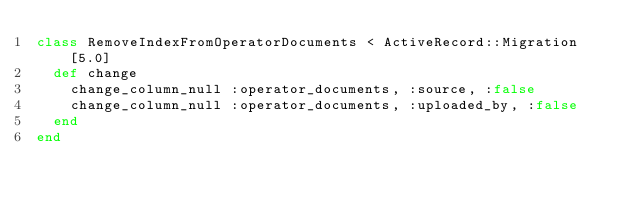Convert code to text. <code><loc_0><loc_0><loc_500><loc_500><_Ruby_>class RemoveIndexFromOperatorDocuments < ActiveRecord::Migration[5.0]
  def change
    change_column_null :operator_documents, :source, :false
    change_column_null :operator_documents, :uploaded_by, :false
  end
end
</code> 